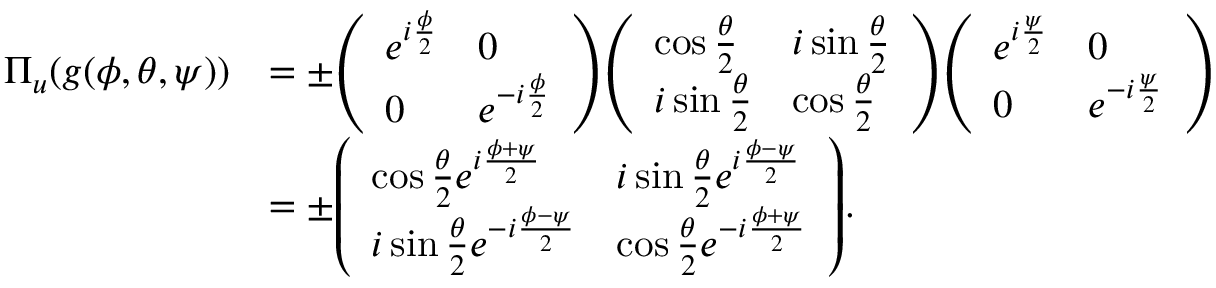Convert formula to latex. <formula><loc_0><loc_0><loc_500><loc_500>{ \begin{array} { r l } { \Pi _ { u } ( g ( \phi , \theta , \psi ) ) } & { = \pm { \left ( \begin{array} { l l } { e ^ { i { \frac { \phi } { 2 } } } } & { 0 } \\ { 0 } & { e ^ { - i { \frac { \phi } { 2 } } } } \end{array} \right ) } { \left ( \begin{array} { l l } { \cos { \frac { \theta } { 2 } } } & { i \sin { \frac { \theta } { 2 } } } \\ { i \sin { \frac { \theta } { 2 } } } & { \cos { \frac { \theta } { 2 } } } \end{array} \right ) } { \left ( \begin{array} { l l } { e ^ { i { \frac { \psi } { 2 } } } } & { 0 } \\ { 0 } & { e ^ { - i { \frac { \psi } { 2 } } } } \end{array} \right ) } } \\ & { = \pm { \left ( \begin{array} { l l } { \cos { \frac { \theta } { 2 } } e ^ { i { \frac { \phi + \psi } { 2 } } } } & { i \sin { \frac { \theta } { 2 } } e ^ { i { \frac { \phi - \psi } { 2 } } } } \\ { i \sin { \frac { \theta } { 2 } } e ^ { - i { \frac { \phi - \psi } { 2 } } } } & { \cos { \frac { \theta } { 2 } } e ^ { - i { \frac { \phi + \psi } { 2 } } } } \end{array} \right ) } . } \end{array} }</formula> 